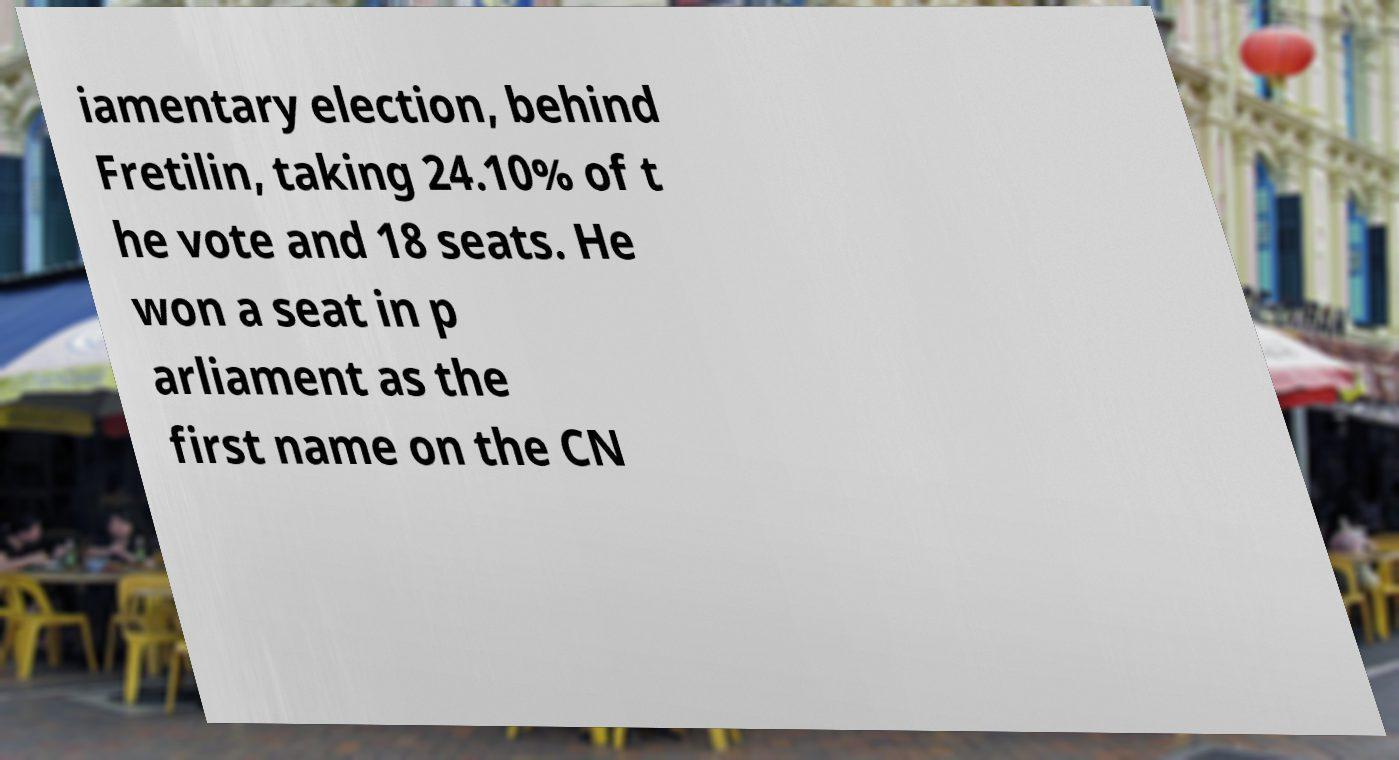What messages or text are displayed in this image? I need them in a readable, typed format. iamentary election, behind Fretilin, taking 24.10% of t he vote and 18 seats. He won a seat in p arliament as the first name on the CN 